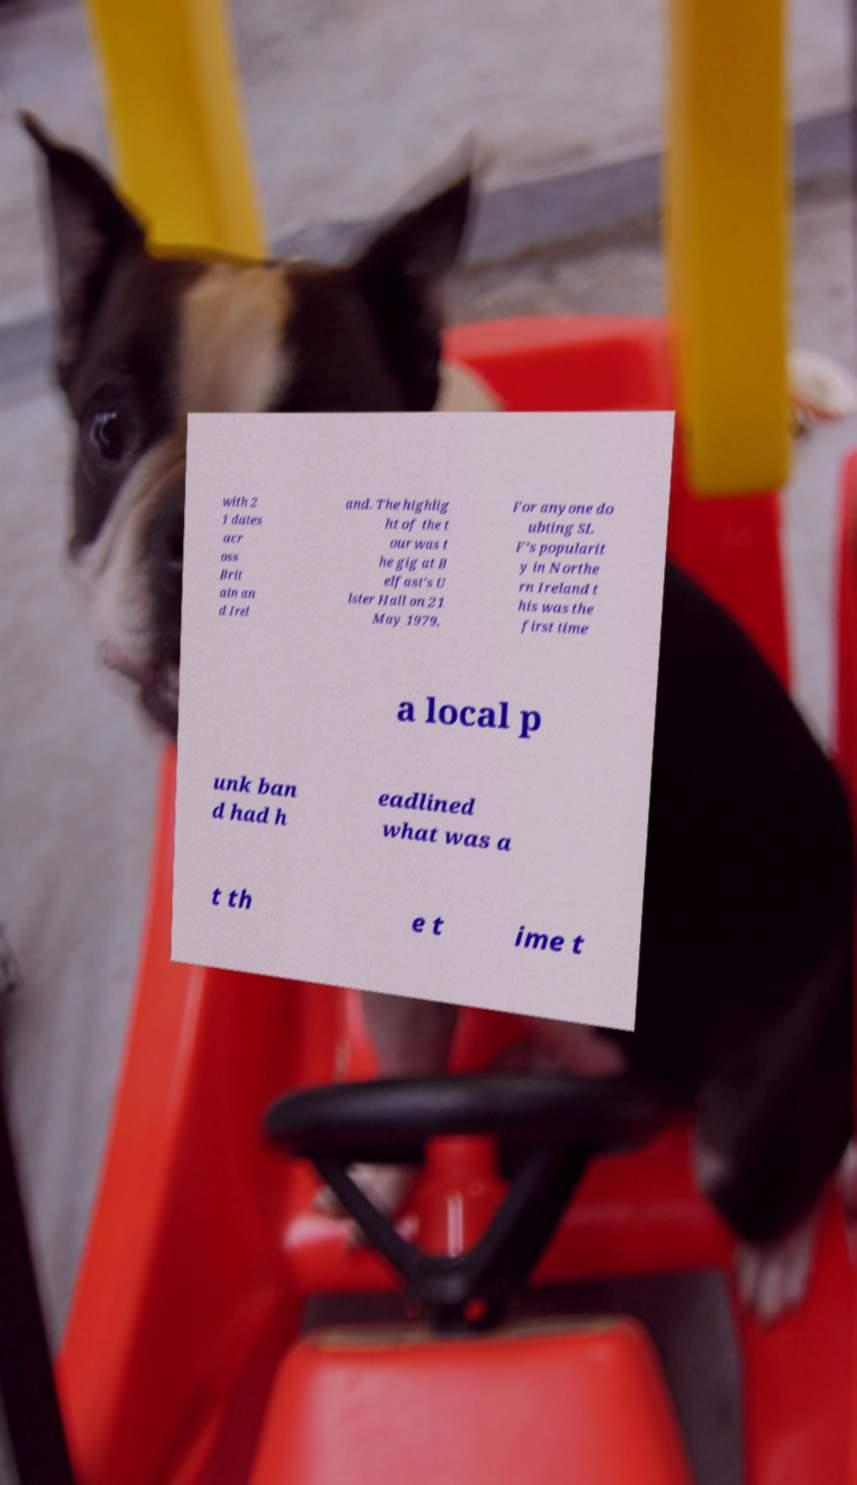Please identify and transcribe the text found in this image. with 2 1 dates acr oss Brit ain an d Irel and. The highlig ht of the t our was t he gig at B elfast's U lster Hall on 21 May 1979. For anyone do ubting SL F’s popularit y in Northe rn Ireland t his was the first time a local p unk ban d had h eadlined what was a t th e t ime t 